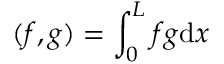<formula> <loc_0><loc_0><loc_500><loc_500>( f , g ) = \int _ { 0 } ^ { L } f g d x</formula> 